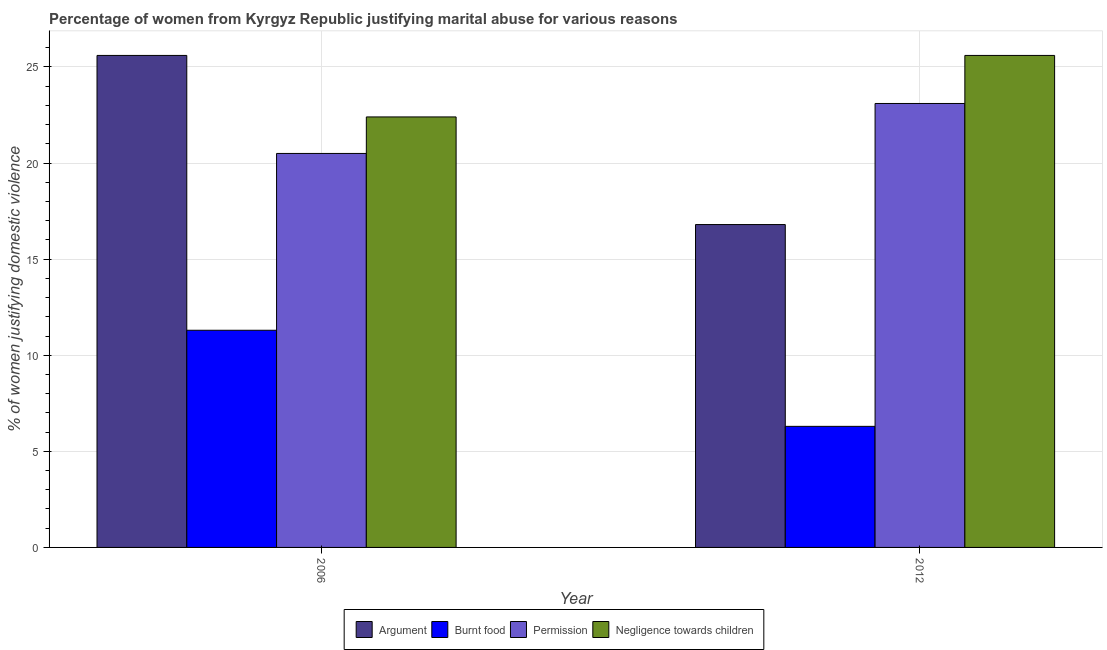How many different coloured bars are there?
Offer a very short reply. 4. How many groups of bars are there?
Your answer should be compact. 2. Are the number of bars on each tick of the X-axis equal?
Offer a very short reply. Yes. How many bars are there on the 2nd tick from the right?
Offer a very short reply. 4. What is the label of the 1st group of bars from the left?
Offer a very short reply. 2006. What is the percentage of women justifying abuse for showing negligence towards children in 2006?
Make the answer very short. 22.4. Across all years, what is the maximum percentage of women justifying abuse for burning food?
Offer a terse response. 11.3. In which year was the percentage of women justifying abuse for burning food maximum?
Ensure brevity in your answer.  2006. In which year was the percentage of women justifying abuse for burning food minimum?
Give a very brief answer. 2012. What is the total percentage of women justifying abuse in the case of an argument in the graph?
Make the answer very short. 42.4. What is the difference between the percentage of women justifying abuse for burning food in 2006 and that in 2012?
Your answer should be compact. 5. What is the average percentage of women justifying abuse for burning food per year?
Make the answer very short. 8.8. In the year 2012, what is the difference between the percentage of women justifying abuse for burning food and percentage of women justifying abuse for going without permission?
Your response must be concise. 0. What is the ratio of the percentage of women justifying abuse for showing negligence towards children in 2006 to that in 2012?
Your answer should be compact. 0.87. Is the percentage of women justifying abuse for going without permission in 2006 less than that in 2012?
Make the answer very short. Yes. In how many years, is the percentage of women justifying abuse for going without permission greater than the average percentage of women justifying abuse for going without permission taken over all years?
Provide a succinct answer. 1. Is it the case that in every year, the sum of the percentage of women justifying abuse for burning food and percentage of women justifying abuse for showing negligence towards children is greater than the sum of percentage of women justifying abuse in the case of an argument and percentage of women justifying abuse for going without permission?
Provide a short and direct response. Yes. What does the 3rd bar from the left in 2006 represents?
Keep it short and to the point. Permission. What does the 2nd bar from the right in 2012 represents?
Provide a short and direct response. Permission. Is it the case that in every year, the sum of the percentage of women justifying abuse in the case of an argument and percentage of women justifying abuse for burning food is greater than the percentage of women justifying abuse for going without permission?
Your response must be concise. No. Are all the bars in the graph horizontal?
Keep it short and to the point. No. How many years are there in the graph?
Offer a very short reply. 2. How many legend labels are there?
Keep it short and to the point. 4. What is the title of the graph?
Provide a short and direct response. Percentage of women from Kyrgyz Republic justifying marital abuse for various reasons. What is the label or title of the Y-axis?
Give a very brief answer. % of women justifying domestic violence. What is the % of women justifying domestic violence in Argument in 2006?
Offer a terse response. 25.6. What is the % of women justifying domestic violence in Negligence towards children in 2006?
Provide a short and direct response. 22.4. What is the % of women justifying domestic violence in Permission in 2012?
Provide a succinct answer. 23.1. What is the % of women justifying domestic violence of Negligence towards children in 2012?
Keep it short and to the point. 25.6. Across all years, what is the maximum % of women justifying domestic violence of Argument?
Provide a succinct answer. 25.6. Across all years, what is the maximum % of women justifying domestic violence of Burnt food?
Keep it short and to the point. 11.3. Across all years, what is the maximum % of women justifying domestic violence of Permission?
Provide a succinct answer. 23.1. Across all years, what is the maximum % of women justifying domestic violence in Negligence towards children?
Provide a succinct answer. 25.6. Across all years, what is the minimum % of women justifying domestic violence of Burnt food?
Provide a short and direct response. 6.3. Across all years, what is the minimum % of women justifying domestic violence in Permission?
Provide a short and direct response. 20.5. Across all years, what is the minimum % of women justifying domestic violence of Negligence towards children?
Keep it short and to the point. 22.4. What is the total % of women justifying domestic violence of Argument in the graph?
Your response must be concise. 42.4. What is the total % of women justifying domestic violence in Burnt food in the graph?
Offer a terse response. 17.6. What is the total % of women justifying domestic violence in Permission in the graph?
Keep it short and to the point. 43.6. What is the total % of women justifying domestic violence in Negligence towards children in the graph?
Your response must be concise. 48. What is the difference between the % of women justifying domestic violence in Burnt food in 2006 and that in 2012?
Make the answer very short. 5. What is the difference between the % of women justifying domestic violence in Argument in 2006 and the % of women justifying domestic violence in Burnt food in 2012?
Give a very brief answer. 19.3. What is the difference between the % of women justifying domestic violence of Argument in 2006 and the % of women justifying domestic violence of Negligence towards children in 2012?
Offer a very short reply. 0. What is the difference between the % of women justifying domestic violence of Burnt food in 2006 and the % of women justifying domestic violence of Permission in 2012?
Offer a terse response. -11.8. What is the difference between the % of women justifying domestic violence of Burnt food in 2006 and the % of women justifying domestic violence of Negligence towards children in 2012?
Ensure brevity in your answer.  -14.3. What is the difference between the % of women justifying domestic violence in Permission in 2006 and the % of women justifying domestic violence in Negligence towards children in 2012?
Ensure brevity in your answer.  -5.1. What is the average % of women justifying domestic violence of Argument per year?
Your answer should be very brief. 21.2. What is the average % of women justifying domestic violence of Burnt food per year?
Make the answer very short. 8.8. What is the average % of women justifying domestic violence of Permission per year?
Your answer should be compact. 21.8. In the year 2006, what is the difference between the % of women justifying domestic violence in Argument and % of women justifying domestic violence in Burnt food?
Your answer should be very brief. 14.3. In the year 2006, what is the difference between the % of women justifying domestic violence in Argument and % of women justifying domestic violence in Permission?
Offer a very short reply. 5.1. In the year 2006, what is the difference between the % of women justifying domestic violence in Argument and % of women justifying domestic violence in Negligence towards children?
Provide a short and direct response. 3.2. In the year 2006, what is the difference between the % of women justifying domestic violence of Burnt food and % of women justifying domestic violence of Permission?
Your answer should be very brief. -9.2. In the year 2012, what is the difference between the % of women justifying domestic violence of Burnt food and % of women justifying domestic violence of Permission?
Your response must be concise. -16.8. In the year 2012, what is the difference between the % of women justifying domestic violence of Burnt food and % of women justifying domestic violence of Negligence towards children?
Your answer should be very brief. -19.3. What is the ratio of the % of women justifying domestic violence in Argument in 2006 to that in 2012?
Ensure brevity in your answer.  1.52. What is the ratio of the % of women justifying domestic violence in Burnt food in 2006 to that in 2012?
Ensure brevity in your answer.  1.79. What is the ratio of the % of women justifying domestic violence of Permission in 2006 to that in 2012?
Make the answer very short. 0.89. What is the ratio of the % of women justifying domestic violence of Negligence towards children in 2006 to that in 2012?
Your answer should be very brief. 0.88. What is the difference between the highest and the second highest % of women justifying domestic violence in Argument?
Your response must be concise. 8.8. What is the difference between the highest and the second highest % of women justifying domestic violence of Burnt food?
Give a very brief answer. 5. What is the difference between the highest and the second highest % of women justifying domestic violence of Permission?
Your answer should be very brief. 2.6. What is the difference between the highest and the second highest % of women justifying domestic violence of Negligence towards children?
Provide a succinct answer. 3.2. What is the difference between the highest and the lowest % of women justifying domestic violence in Argument?
Provide a succinct answer. 8.8. What is the difference between the highest and the lowest % of women justifying domestic violence of Burnt food?
Your answer should be compact. 5. What is the difference between the highest and the lowest % of women justifying domestic violence of Permission?
Offer a very short reply. 2.6. What is the difference between the highest and the lowest % of women justifying domestic violence of Negligence towards children?
Your answer should be compact. 3.2. 